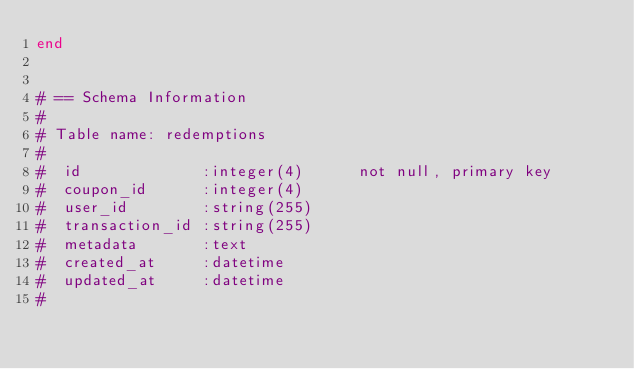Convert code to text. <code><loc_0><loc_0><loc_500><loc_500><_Ruby_>end


# == Schema Information
#
# Table name: redemptions
#
#  id             :integer(4)      not null, primary key
#  coupon_id      :integer(4)
#  user_id        :string(255)
#  transaction_id :string(255)
#  metadata       :text
#  created_at     :datetime
#  updated_at     :datetime
#

</code> 